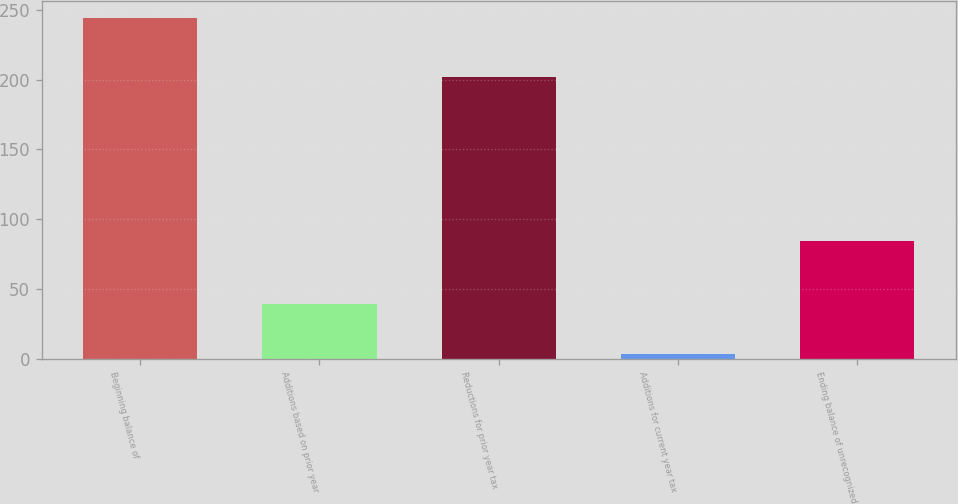Convert chart. <chart><loc_0><loc_0><loc_500><loc_500><bar_chart><fcel>Beginning balance of<fcel>Additions based on prior year<fcel>Reductions for prior year tax<fcel>Additions for current year tax<fcel>Ending balance of unrecognized<nl><fcel>244<fcel>39<fcel>202<fcel>3<fcel>84<nl></chart> 